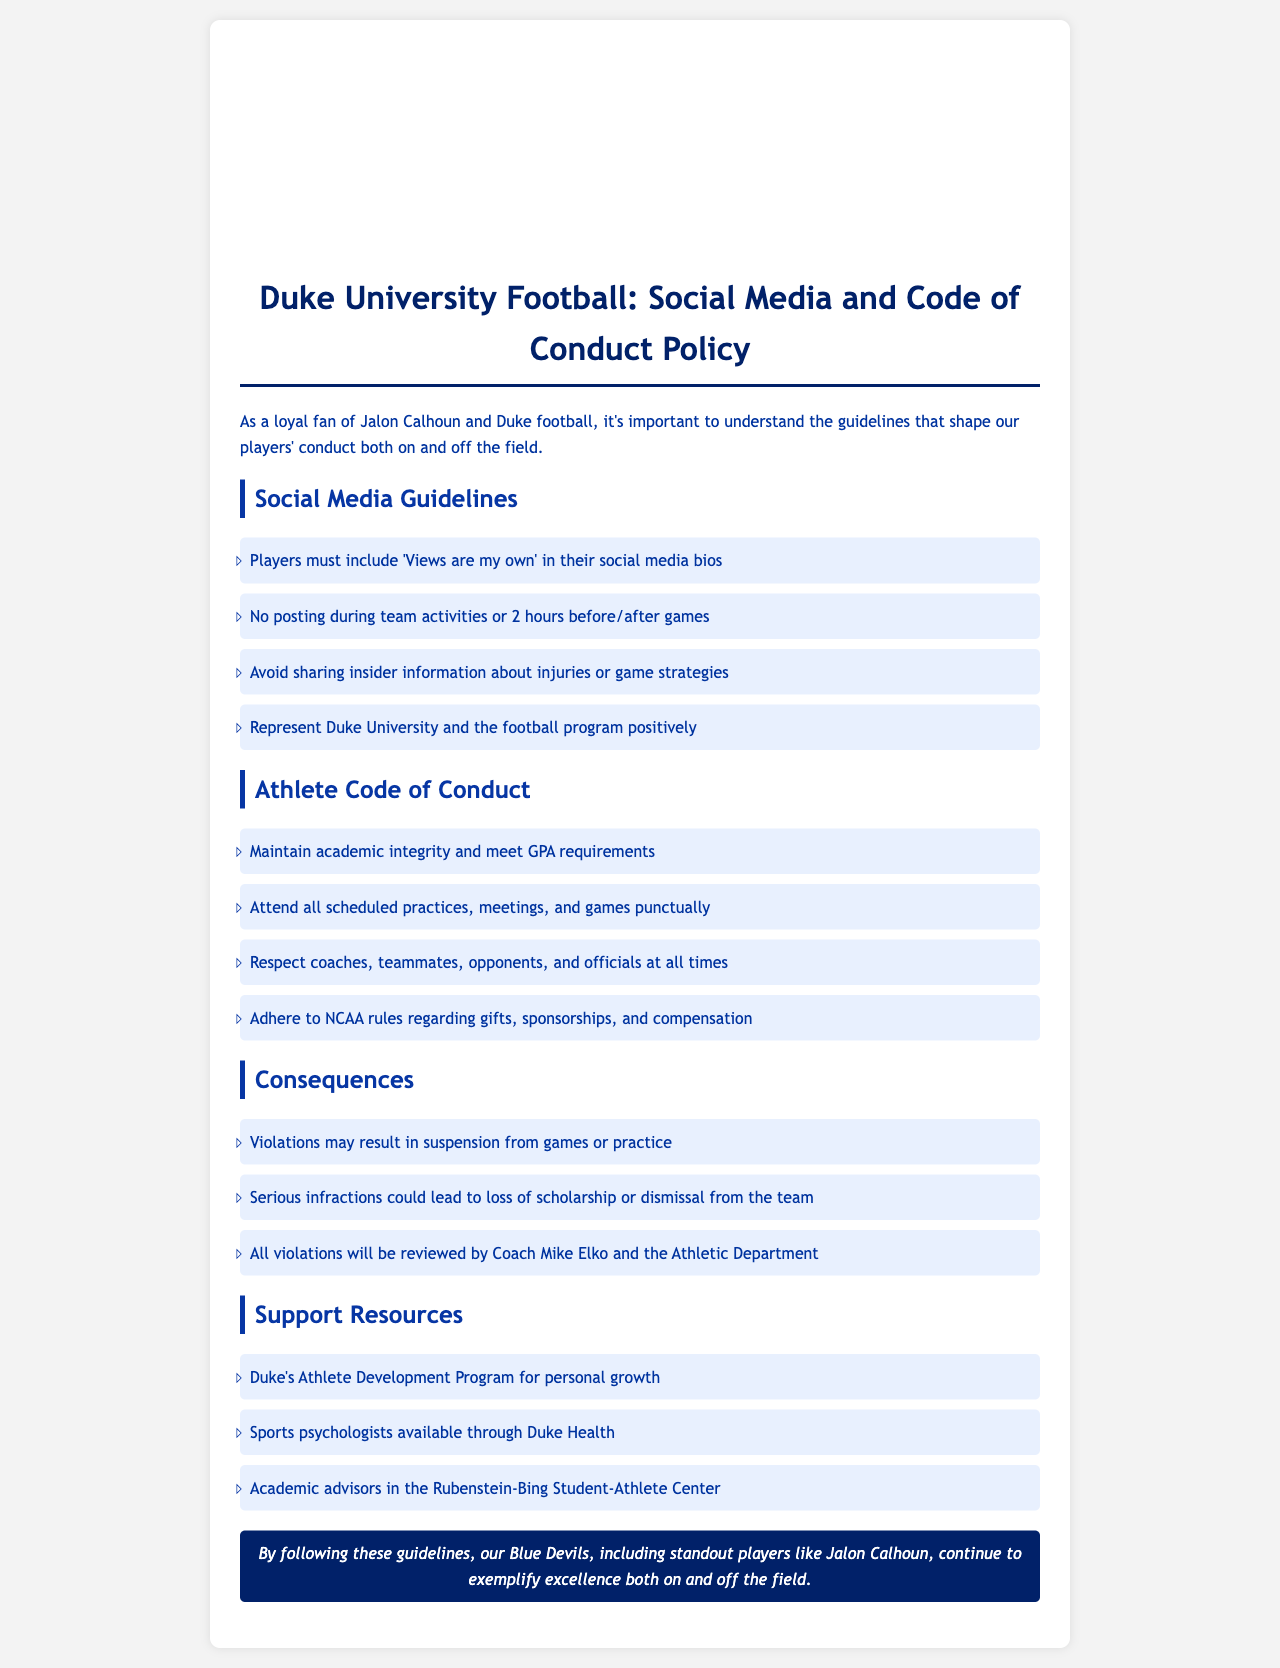What must players include in their social media bios? The document states that players must include 'Views are my own' in their social media bios.
Answer: 'Views are my own' How long before or after games are players prohibited from posting? Players are prohibited from posting for 2 hours before and after games.
Answer: 2 hours Who reviews all violations of the athlete code of conduct? All violations will be reviewed by Coach Mike Elko and the Athletic Department.
Answer: Coach Mike Elko and the Athletic Department What is the consequence of serious infractions according to the document? Serious infractions could lead to loss of scholarship or dismissal from the team.
Answer: Loss of scholarship or dismissal from the team What program is available for personal growth to players? The document mentions Duke's Athlete Development Program for personal growth.
Answer: Duke's Athlete Development Program 